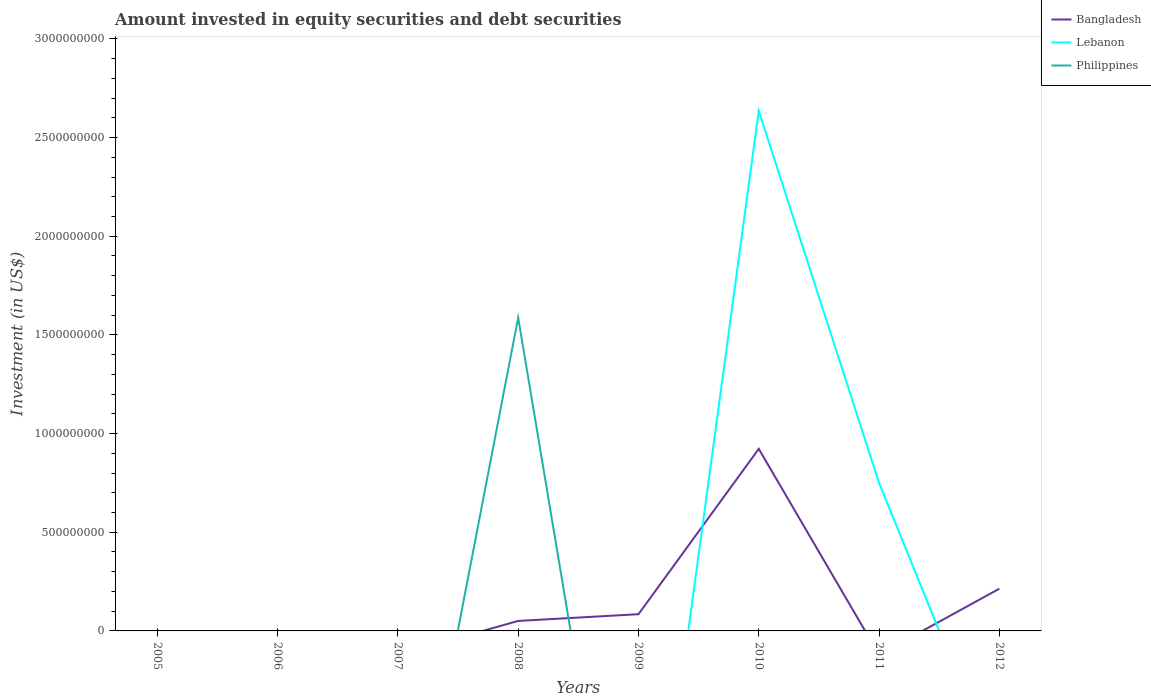How many different coloured lines are there?
Your answer should be compact. 3. Is the number of lines equal to the number of legend labels?
Offer a very short reply. No. What is the difference between the highest and the second highest amount invested in equity securities and debt securities in Lebanon?
Your response must be concise. 2.64e+09. Is the amount invested in equity securities and debt securities in Philippines strictly greater than the amount invested in equity securities and debt securities in Lebanon over the years?
Ensure brevity in your answer.  No. Are the values on the major ticks of Y-axis written in scientific E-notation?
Keep it short and to the point. No. What is the title of the graph?
Offer a very short reply. Amount invested in equity securities and debt securities. What is the label or title of the X-axis?
Your answer should be very brief. Years. What is the label or title of the Y-axis?
Offer a very short reply. Investment (in US$). What is the Investment (in US$) in Bangladesh in 2005?
Keep it short and to the point. 0. What is the Investment (in US$) in Bangladesh in 2006?
Ensure brevity in your answer.  0. What is the Investment (in US$) of Philippines in 2006?
Make the answer very short. 0. What is the Investment (in US$) of Bangladesh in 2007?
Offer a terse response. 0. What is the Investment (in US$) in Philippines in 2007?
Provide a succinct answer. 0. What is the Investment (in US$) in Bangladesh in 2008?
Your response must be concise. 5.06e+07. What is the Investment (in US$) of Lebanon in 2008?
Make the answer very short. 0. What is the Investment (in US$) in Philippines in 2008?
Give a very brief answer. 1.59e+09. What is the Investment (in US$) in Bangladesh in 2009?
Your answer should be very brief. 8.47e+07. What is the Investment (in US$) in Philippines in 2009?
Your response must be concise. 0. What is the Investment (in US$) of Bangladesh in 2010?
Ensure brevity in your answer.  9.23e+08. What is the Investment (in US$) of Lebanon in 2010?
Offer a very short reply. 2.64e+09. What is the Investment (in US$) in Philippines in 2010?
Offer a terse response. 0. What is the Investment (in US$) in Lebanon in 2011?
Your answer should be compact. 7.50e+08. What is the Investment (in US$) of Philippines in 2011?
Your response must be concise. 0. What is the Investment (in US$) of Bangladesh in 2012?
Provide a succinct answer. 2.14e+08. What is the Investment (in US$) in Lebanon in 2012?
Ensure brevity in your answer.  0. Across all years, what is the maximum Investment (in US$) of Bangladesh?
Your answer should be very brief. 9.23e+08. Across all years, what is the maximum Investment (in US$) of Lebanon?
Give a very brief answer. 2.64e+09. Across all years, what is the maximum Investment (in US$) of Philippines?
Provide a short and direct response. 1.59e+09. Across all years, what is the minimum Investment (in US$) of Philippines?
Give a very brief answer. 0. What is the total Investment (in US$) in Bangladesh in the graph?
Give a very brief answer. 1.27e+09. What is the total Investment (in US$) in Lebanon in the graph?
Your answer should be very brief. 3.39e+09. What is the total Investment (in US$) in Philippines in the graph?
Your answer should be compact. 1.59e+09. What is the difference between the Investment (in US$) of Bangladesh in 2008 and that in 2009?
Your answer should be compact. -3.41e+07. What is the difference between the Investment (in US$) in Bangladesh in 2008 and that in 2010?
Provide a short and direct response. -8.72e+08. What is the difference between the Investment (in US$) in Bangladesh in 2008 and that in 2012?
Ensure brevity in your answer.  -1.63e+08. What is the difference between the Investment (in US$) in Bangladesh in 2009 and that in 2010?
Make the answer very short. -8.38e+08. What is the difference between the Investment (in US$) in Bangladesh in 2009 and that in 2012?
Keep it short and to the point. -1.29e+08. What is the difference between the Investment (in US$) of Lebanon in 2010 and that in 2011?
Provide a short and direct response. 1.89e+09. What is the difference between the Investment (in US$) of Bangladesh in 2010 and that in 2012?
Ensure brevity in your answer.  7.09e+08. What is the difference between the Investment (in US$) of Bangladesh in 2008 and the Investment (in US$) of Lebanon in 2010?
Your answer should be very brief. -2.58e+09. What is the difference between the Investment (in US$) of Bangladesh in 2008 and the Investment (in US$) of Lebanon in 2011?
Give a very brief answer. -6.99e+08. What is the difference between the Investment (in US$) of Bangladesh in 2009 and the Investment (in US$) of Lebanon in 2010?
Give a very brief answer. -2.55e+09. What is the difference between the Investment (in US$) of Bangladesh in 2009 and the Investment (in US$) of Lebanon in 2011?
Give a very brief answer. -6.65e+08. What is the difference between the Investment (in US$) of Bangladesh in 2010 and the Investment (in US$) of Lebanon in 2011?
Offer a terse response. 1.73e+08. What is the average Investment (in US$) of Bangladesh per year?
Offer a very short reply. 1.59e+08. What is the average Investment (in US$) in Lebanon per year?
Give a very brief answer. 4.23e+08. What is the average Investment (in US$) in Philippines per year?
Ensure brevity in your answer.  1.98e+08. In the year 2008, what is the difference between the Investment (in US$) of Bangladesh and Investment (in US$) of Philippines?
Offer a very short reply. -1.54e+09. In the year 2010, what is the difference between the Investment (in US$) in Bangladesh and Investment (in US$) in Lebanon?
Your answer should be compact. -1.71e+09. What is the ratio of the Investment (in US$) in Bangladesh in 2008 to that in 2009?
Keep it short and to the point. 0.6. What is the ratio of the Investment (in US$) of Bangladesh in 2008 to that in 2010?
Your response must be concise. 0.05. What is the ratio of the Investment (in US$) of Bangladesh in 2008 to that in 2012?
Your response must be concise. 0.24. What is the ratio of the Investment (in US$) in Bangladesh in 2009 to that in 2010?
Provide a succinct answer. 0.09. What is the ratio of the Investment (in US$) of Bangladesh in 2009 to that in 2012?
Make the answer very short. 0.4. What is the ratio of the Investment (in US$) in Lebanon in 2010 to that in 2011?
Offer a terse response. 3.51. What is the ratio of the Investment (in US$) of Bangladesh in 2010 to that in 2012?
Keep it short and to the point. 4.31. What is the difference between the highest and the second highest Investment (in US$) of Bangladesh?
Your answer should be compact. 7.09e+08. What is the difference between the highest and the lowest Investment (in US$) of Bangladesh?
Offer a very short reply. 9.23e+08. What is the difference between the highest and the lowest Investment (in US$) of Lebanon?
Offer a terse response. 2.64e+09. What is the difference between the highest and the lowest Investment (in US$) of Philippines?
Offer a very short reply. 1.59e+09. 